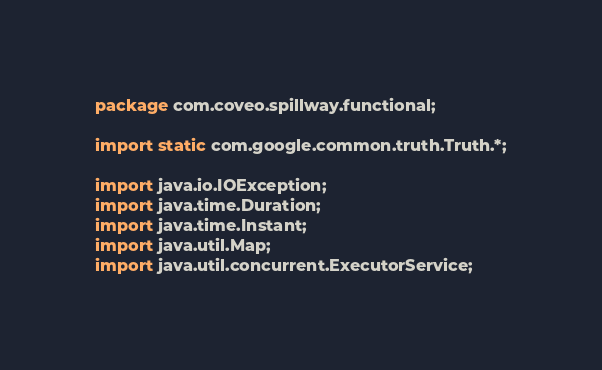<code> <loc_0><loc_0><loc_500><loc_500><_Java_>package com.coveo.spillway.functional;

import static com.google.common.truth.Truth.*;

import java.io.IOException;
import java.time.Duration;
import java.time.Instant;
import java.util.Map;
import java.util.concurrent.ExecutorService;</code> 